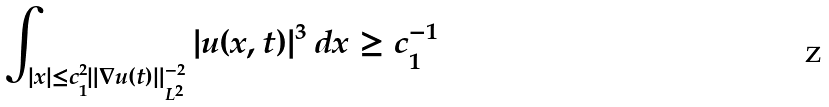<formula> <loc_0><loc_0><loc_500><loc_500>\int _ { | x | \leq c _ { 1 } ^ { 2 } \| \nabla u ( t ) \| _ { L ^ { 2 } } ^ { - 2 } } | u ( x , t ) | ^ { 3 } \, d x \geq c _ { 1 } ^ { - 1 }</formula> 